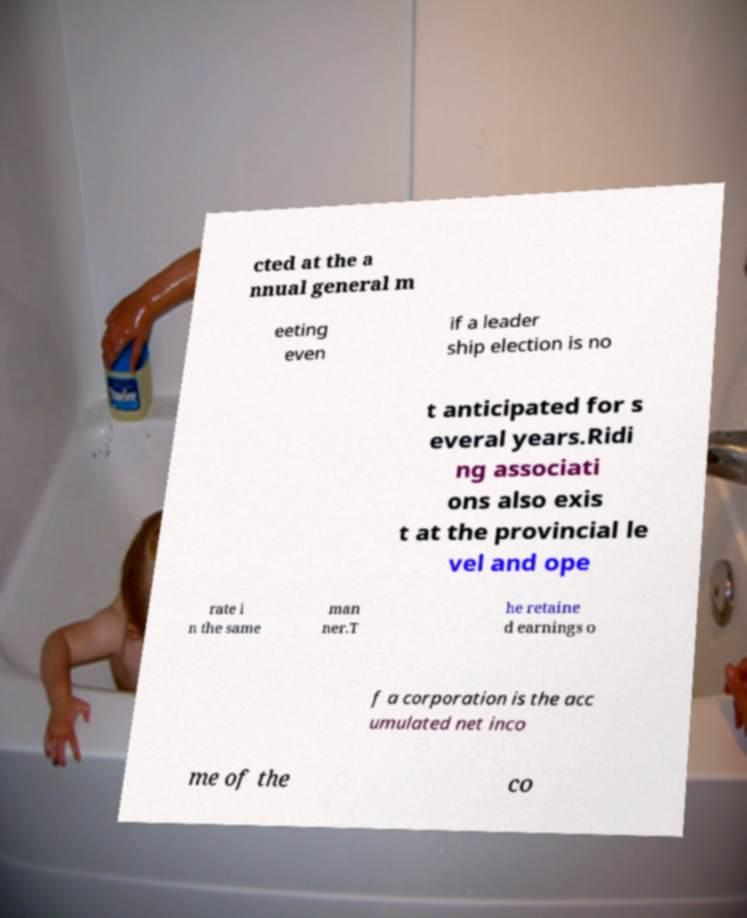Can you accurately transcribe the text from the provided image for me? cted at the a nnual general m eeting even if a leader ship election is no t anticipated for s everal years.Ridi ng associati ons also exis t at the provincial le vel and ope rate i n the same man ner.T he retaine d earnings o f a corporation is the acc umulated net inco me of the co 